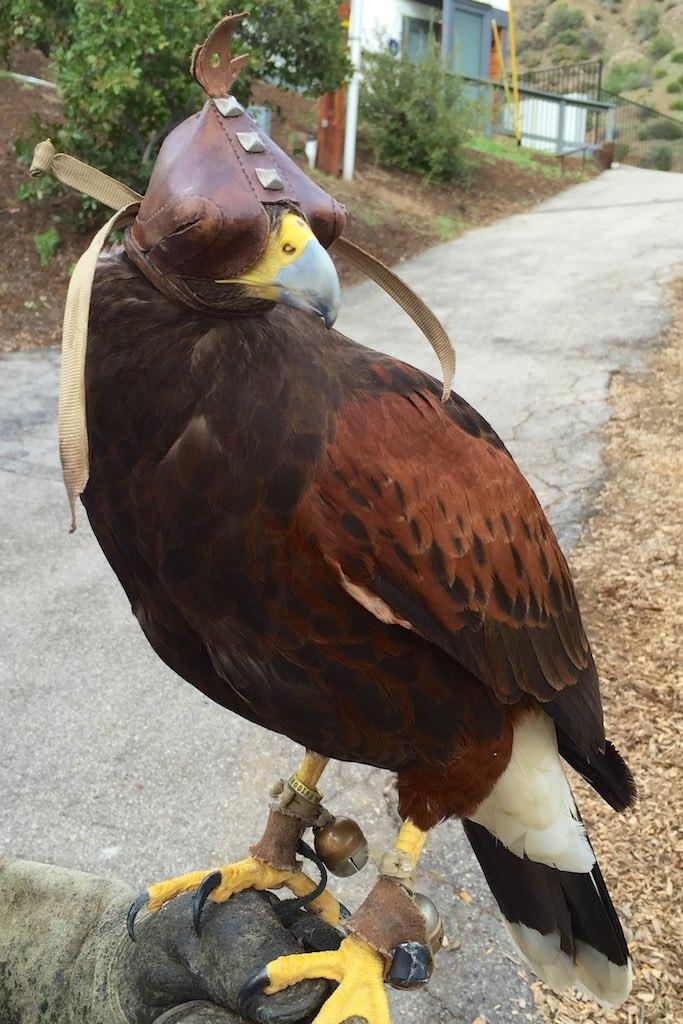What type of animal can be seen in the image? There is a bird in the image. What can be seen in the background of the image? There are trees, a house, a fence, and a mountain in the background of the image. When was the image taken? The image was taken during the day. What type of zinc is present on the table in the image? There is no zinc or table present in the image. How many rooms can be seen in the image? There is no room visible in the image; it features a bird and various background elements. 